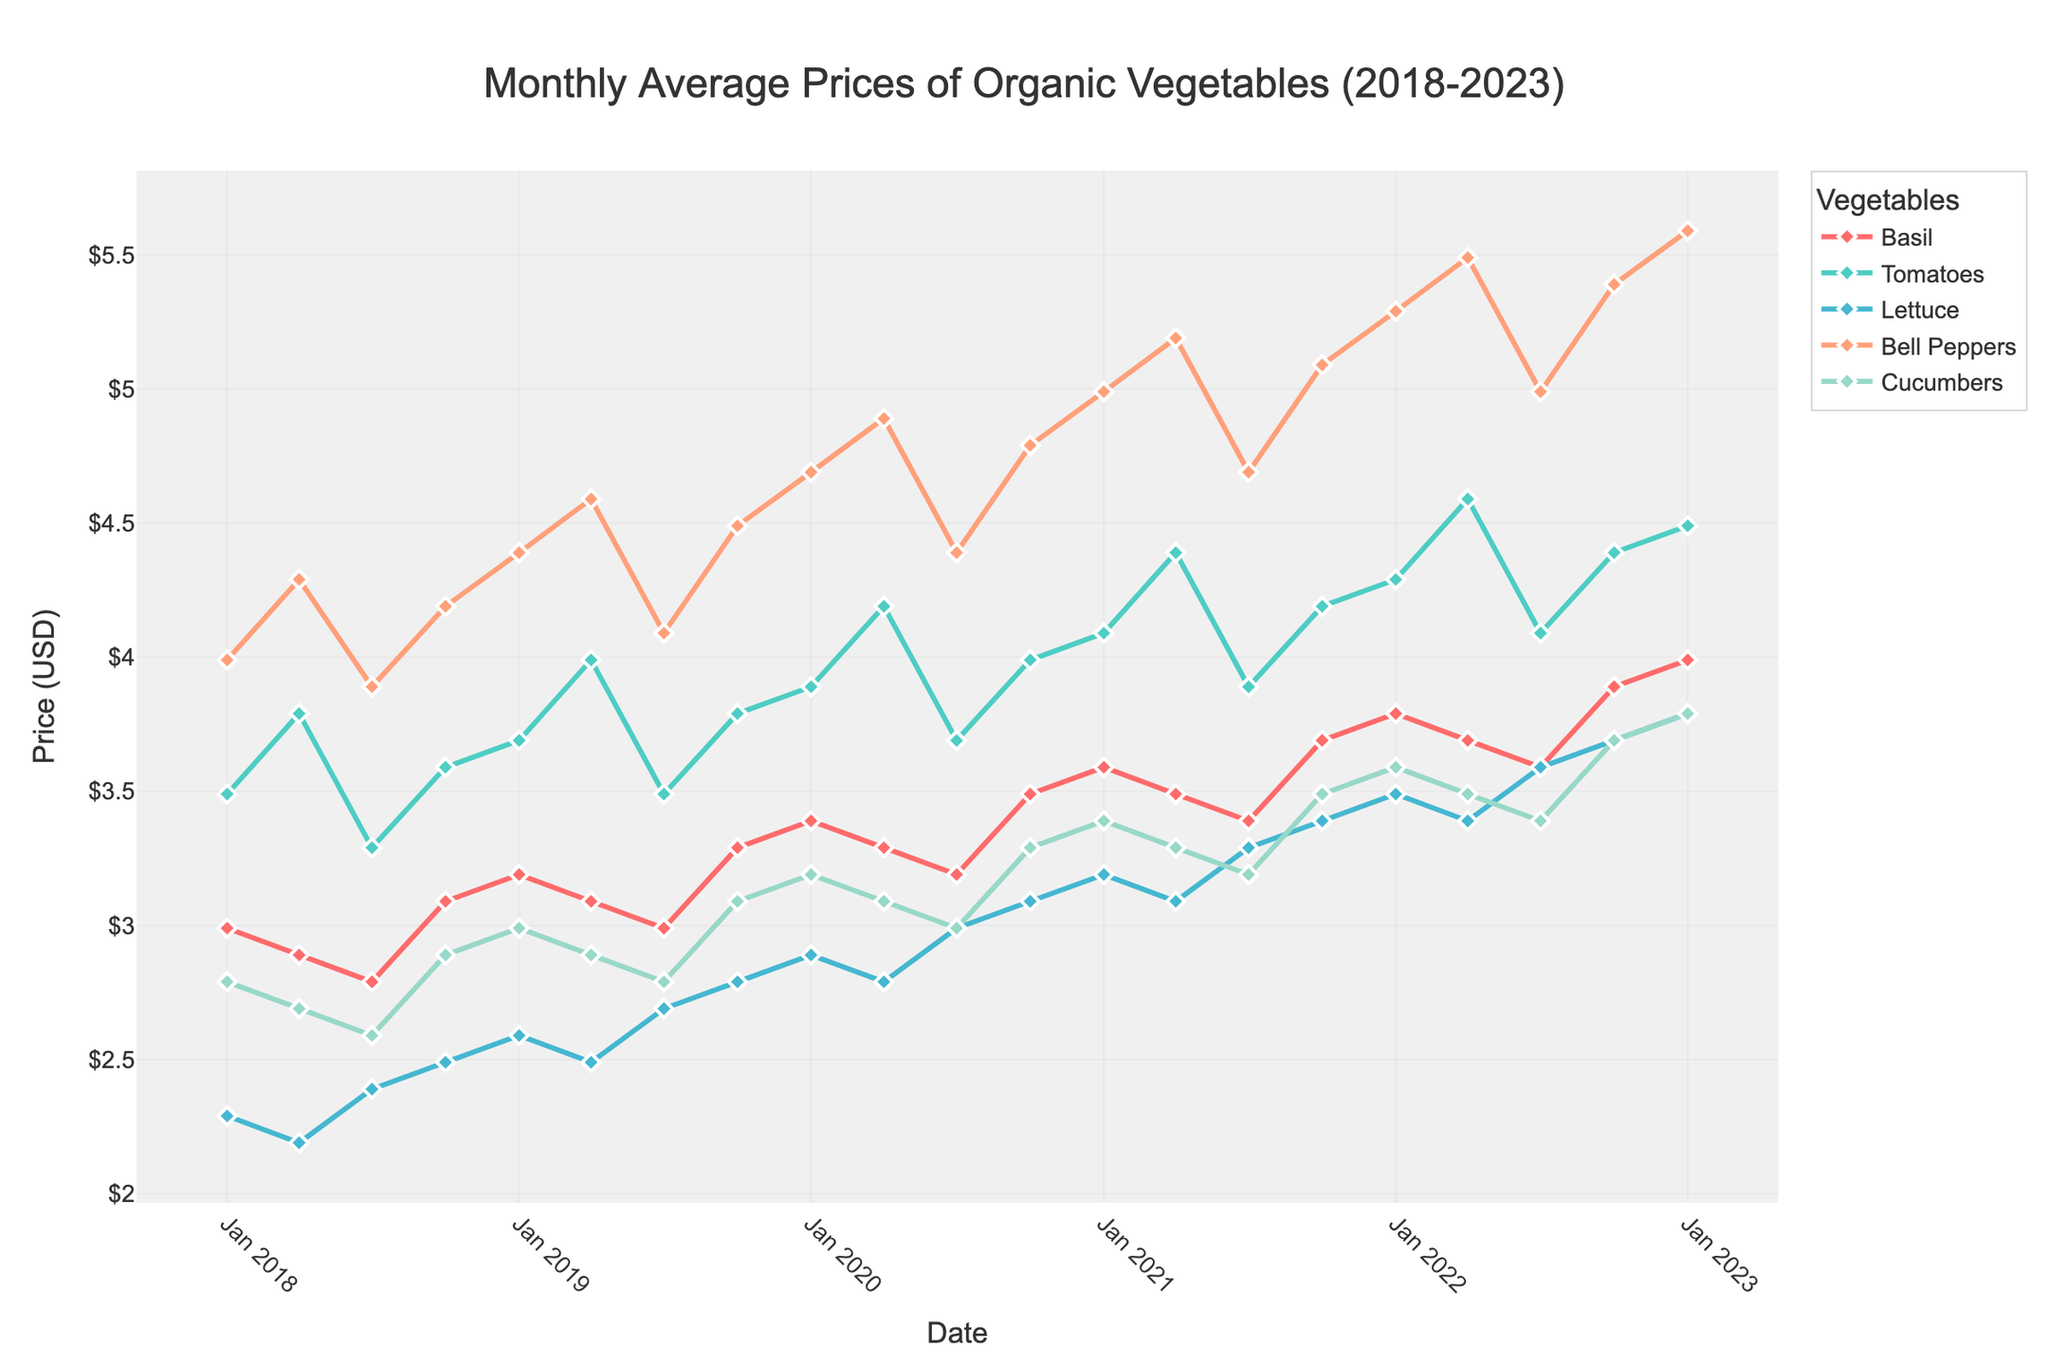What is the highest recorded price for Basil from 2018 to 2023? To find the highest price for Basil, look at the Basil line in the plot and identify the peak point. From the chart, the highest point appears to be at the most recent date.
Answer: $3.99 What was the price trend for Bell Peppers from Jan 2018 to Jan 2023? To determine the trend, observe the line representing Bell Peppers. Notice the fluctuations and whether the general direction is upward, downward, or stable. From the chart, the price of Bell Peppers generally increases over time.
Answer: Increasing How do the prices of Cucumbers in Jan 2018 and Jan 2023 compare? Locate the points for Cucumbers in Jan 2018 and Jan 2023 on the plot. Compare their Y-axis values. In Jan 2018, the price is $2.79, and in Jan 2023, it is $3.79.
Answer: Jan 2023 is higher What is the average price of Tomatoes in 2019? Identify the price points for Tomatoes in 2019 on the plot. These points are in Jan, Apr, Jul, and Oct. The prices are $3.69, $3.99, $3.49, and $3.79 respectively. Compute the average as (3.69 + 3.99 + 3.49 + 3.79) / 4 = 3.74.
Answer: $3.74 Which vegetable had the most consistent prices over the 5-year period? Consistency in prices would be indicated by the least fluctuation in the respective line for each vegetable. Observing the chart, Lettuce seems to show the least variation in price over the 5-year period.
Answer: Lettuce Which vegetable had the steepest price increase between Jan 2020 and Jan 2023? Look for the rate of change between Jan 2020 and Jan 2023 for each vegetable. Observe the differences in the starting and ending points for these dates for each line. Bell Peppers show the most significant increase from $4.69 to $5.59.
Answer: Bell Peppers What can you say about the price pattern for Basil in 2021? Observe the Basil line within the year 2021. Identify how the prices change from Jan, Apr, Jul, and Oct. The price starts at $3.59 in Jan, slightly decreases to $3.49 in Apr, then rises to $3.69 by Oct.
Answer: Slightly fluctuating, then increasing How does the price of Lettuce in Jul 2022 compare to the price in Jul 2018? Locate the points for Lettuce in Jul 2022 and Jul 2018. Compare their values. In Jul 2022, the price is $3.59, and in Jul 2018, it is $2.39.
Answer: Jul 2022 is higher 